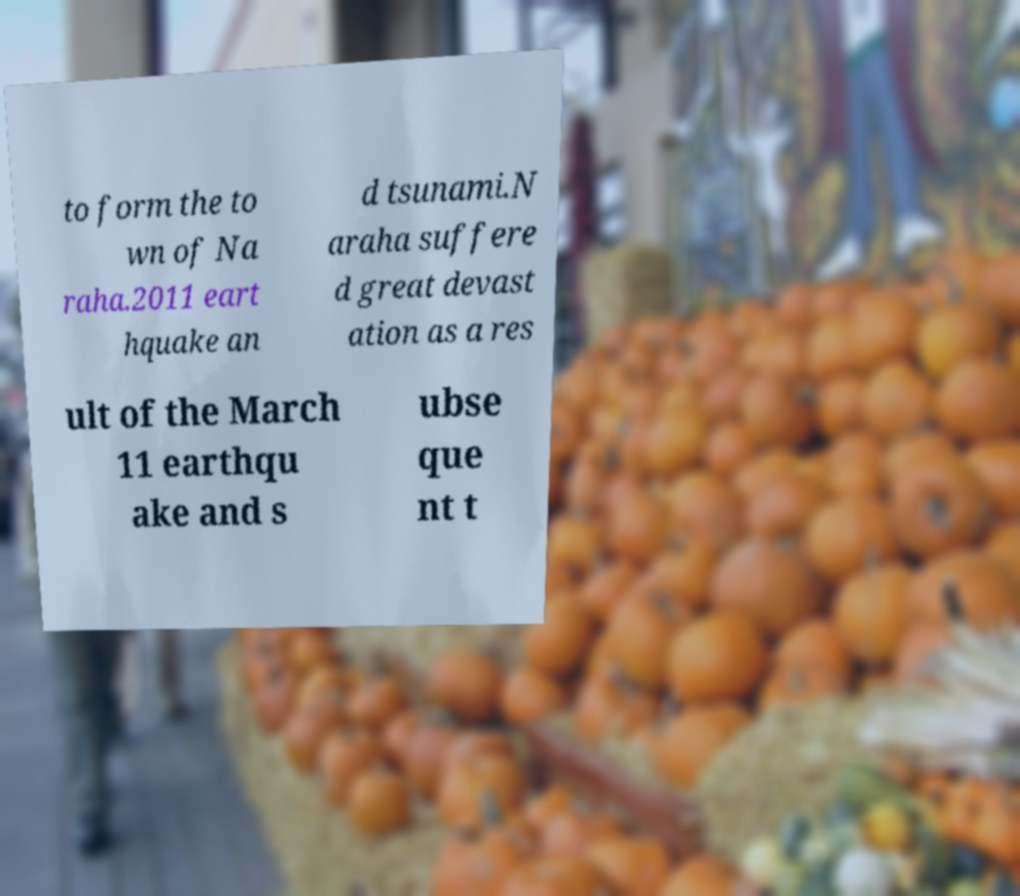There's text embedded in this image that I need extracted. Can you transcribe it verbatim? to form the to wn of Na raha.2011 eart hquake an d tsunami.N araha suffere d great devast ation as a res ult of the March 11 earthqu ake and s ubse que nt t 